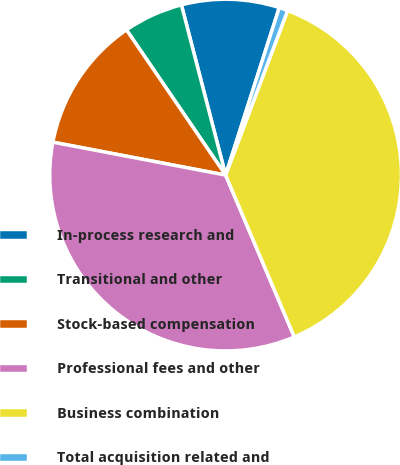Convert chart to OTSL. <chart><loc_0><loc_0><loc_500><loc_500><pie_chart><fcel>In-process research and<fcel>Transitional and other<fcel>Stock-based compensation<fcel>Professional fees and other<fcel>Business combination<fcel>Total acquisition related and<nl><fcel>8.98%<fcel>5.49%<fcel>12.47%<fcel>34.39%<fcel>37.88%<fcel>0.8%<nl></chart> 